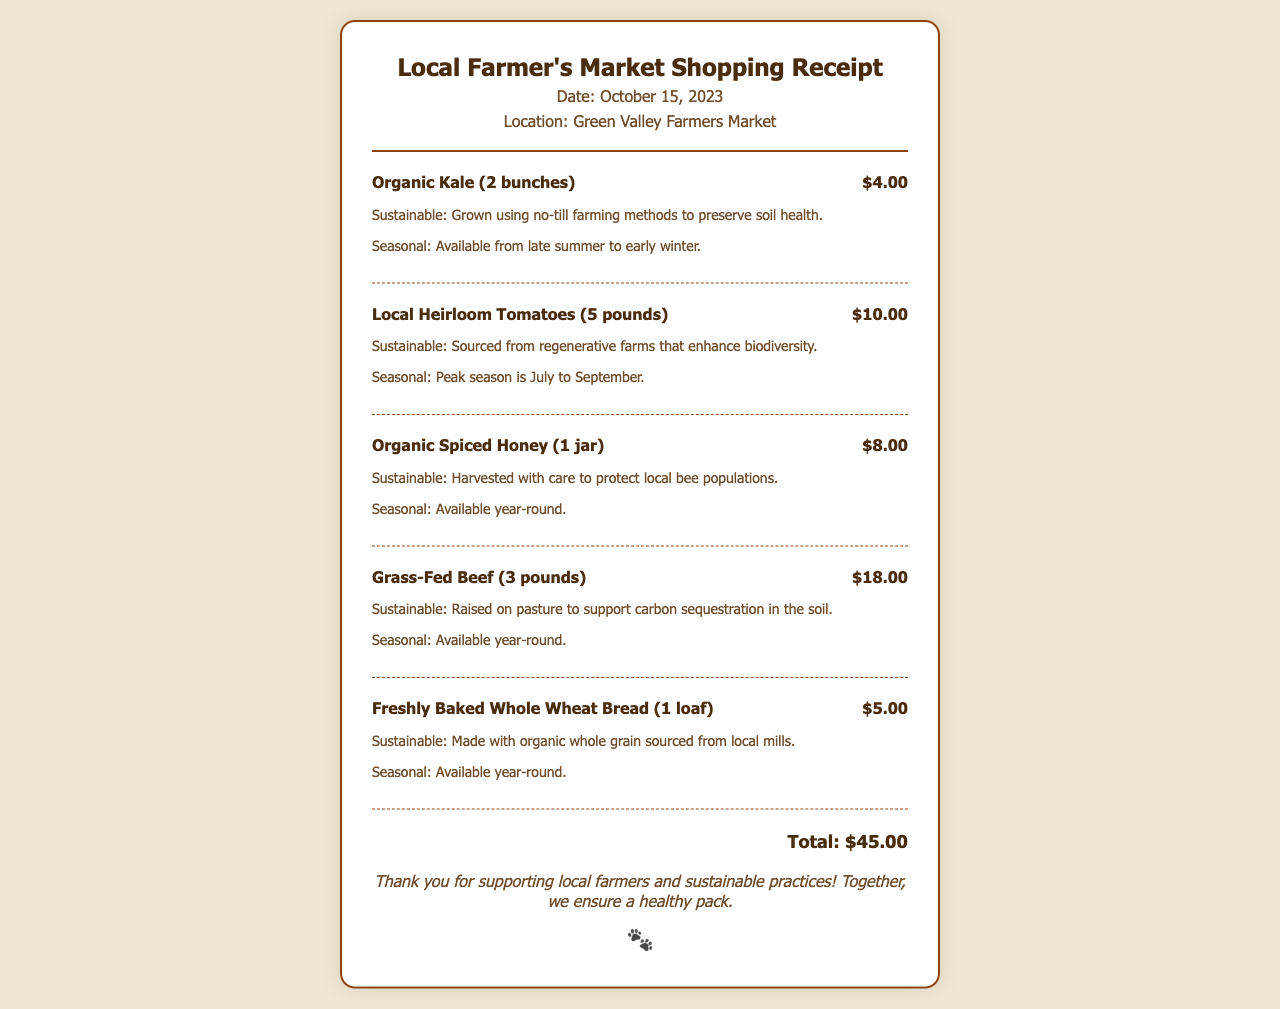What is the date of the receipt? The date of the receipt can be found in the header section of the document, which states "Date: October 15, 2023."
Answer: October 15, 2023 Where was the shopping done? The location of the shopping can be found next to the date in the header, which states "Location: Green Valley Farmers Market."
Answer: Green Valley Farmers Market How much did the organic kale cost? The price of the organic kale is listed next to its name in the item section, which states "$4.00."
Answer: $4.00 What sustainable practice is used for the grass-fed beef? The sustainable practice for grass-fed beef is mentioned in its item details, which states "Raised on pasture to support carbon sequestration in the soil."
Answer: Raised on pasture Which item is available year-round? Based on the item details, multiple items state they are available year-round; one example is organic spiced honey.
Answer: Organic spiced honey How many pounds of heirloom tomatoes were purchased? The quantity of heirloom tomatoes is listed next to its name in the item section, which states "5 pounds."
Answer: 5 pounds What is the total amount spent? The total amount is specified at the bottom of the receipt, which states "Total: $45.00."
Answer: $45.00 What season is the organic kale available in? The seasonality of the organic kale is mentioned in the item details, which states "Available from late summer to early winter."
Answer: Late summer to early winter What message is conveyed at the end of the receipt? The message is included in the message section of the receipt, signifying support for local farmers, which states "Thank you for supporting local farmers and sustainable practices!"
Answer: Thank you for supporting local farmers and sustainable practices! 